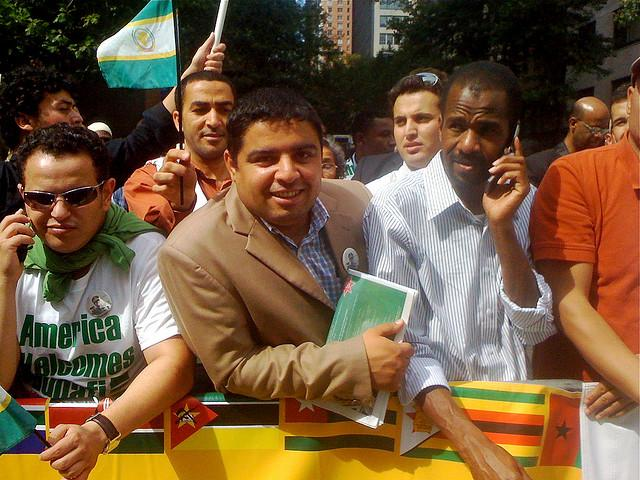What is the man holding the paper wearing? blazer 